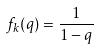<formula> <loc_0><loc_0><loc_500><loc_500>f _ { k } ( q ) = \frac { 1 } { 1 - q }</formula> 